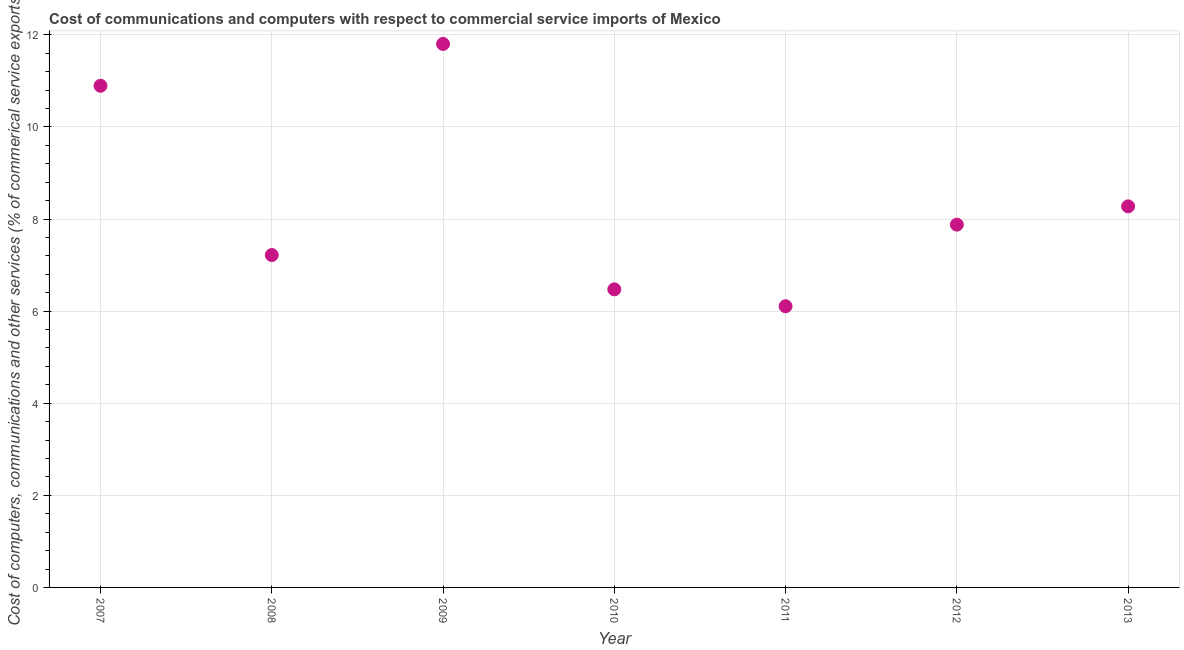What is the  computer and other services in 2010?
Keep it short and to the point. 6.47. Across all years, what is the maximum  computer and other services?
Your response must be concise. 11.8. Across all years, what is the minimum  computer and other services?
Your answer should be compact. 6.11. In which year was the  computer and other services maximum?
Your answer should be compact. 2009. What is the sum of the cost of communications?
Keep it short and to the point. 58.64. What is the difference between the  computer and other services in 2011 and 2012?
Give a very brief answer. -1.77. What is the average cost of communications per year?
Your answer should be very brief. 8.38. What is the median cost of communications?
Make the answer very short. 7.88. What is the ratio of the  computer and other services in 2007 to that in 2008?
Offer a very short reply. 1.51. Is the cost of communications in 2009 less than that in 2012?
Offer a very short reply. No. Is the difference between the cost of communications in 2008 and 2012 greater than the difference between any two years?
Offer a terse response. No. What is the difference between the highest and the second highest cost of communications?
Ensure brevity in your answer.  0.91. What is the difference between the highest and the lowest  computer and other services?
Your response must be concise. 5.7. In how many years, is the cost of communications greater than the average cost of communications taken over all years?
Keep it short and to the point. 2. Does the cost of communications monotonically increase over the years?
Your response must be concise. No. How many years are there in the graph?
Your response must be concise. 7. What is the difference between two consecutive major ticks on the Y-axis?
Make the answer very short. 2. Are the values on the major ticks of Y-axis written in scientific E-notation?
Offer a terse response. No. What is the title of the graph?
Your answer should be very brief. Cost of communications and computers with respect to commercial service imports of Mexico. What is the label or title of the Y-axis?
Provide a short and direct response. Cost of computers, communications and other services (% of commerical service exports). What is the Cost of computers, communications and other services (% of commerical service exports) in 2007?
Provide a succinct answer. 10.89. What is the Cost of computers, communications and other services (% of commerical service exports) in 2008?
Give a very brief answer. 7.22. What is the Cost of computers, communications and other services (% of commerical service exports) in 2009?
Make the answer very short. 11.8. What is the Cost of computers, communications and other services (% of commerical service exports) in 2010?
Make the answer very short. 6.47. What is the Cost of computers, communications and other services (% of commerical service exports) in 2011?
Keep it short and to the point. 6.11. What is the Cost of computers, communications and other services (% of commerical service exports) in 2012?
Your answer should be compact. 7.88. What is the Cost of computers, communications and other services (% of commerical service exports) in 2013?
Make the answer very short. 8.27. What is the difference between the Cost of computers, communications and other services (% of commerical service exports) in 2007 and 2008?
Provide a short and direct response. 3.67. What is the difference between the Cost of computers, communications and other services (% of commerical service exports) in 2007 and 2009?
Your answer should be very brief. -0.91. What is the difference between the Cost of computers, communications and other services (% of commerical service exports) in 2007 and 2010?
Give a very brief answer. 4.42. What is the difference between the Cost of computers, communications and other services (% of commerical service exports) in 2007 and 2011?
Offer a terse response. 4.79. What is the difference between the Cost of computers, communications and other services (% of commerical service exports) in 2007 and 2012?
Provide a succinct answer. 3.01. What is the difference between the Cost of computers, communications and other services (% of commerical service exports) in 2007 and 2013?
Make the answer very short. 2.62. What is the difference between the Cost of computers, communications and other services (% of commerical service exports) in 2008 and 2009?
Provide a succinct answer. -4.58. What is the difference between the Cost of computers, communications and other services (% of commerical service exports) in 2008 and 2010?
Make the answer very short. 0.75. What is the difference between the Cost of computers, communications and other services (% of commerical service exports) in 2008 and 2011?
Offer a very short reply. 1.11. What is the difference between the Cost of computers, communications and other services (% of commerical service exports) in 2008 and 2012?
Offer a very short reply. -0.66. What is the difference between the Cost of computers, communications and other services (% of commerical service exports) in 2008 and 2013?
Your answer should be very brief. -1.06. What is the difference between the Cost of computers, communications and other services (% of commerical service exports) in 2009 and 2010?
Ensure brevity in your answer.  5.33. What is the difference between the Cost of computers, communications and other services (% of commerical service exports) in 2009 and 2011?
Provide a succinct answer. 5.7. What is the difference between the Cost of computers, communications and other services (% of commerical service exports) in 2009 and 2012?
Make the answer very short. 3.92. What is the difference between the Cost of computers, communications and other services (% of commerical service exports) in 2009 and 2013?
Your answer should be very brief. 3.53. What is the difference between the Cost of computers, communications and other services (% of commerical service exports) in 2010 and 2011?
Provide a succinct answer. 0.37. What is the difference between the Cost of computers, communications and other services (% of commerical service exports) in 2010 and 2012?
Make the answer very short. -1.41. What is the difference between the Cost of computers, communications and other services (% of commerical service exports) in 2010 and 2013?
Keep it short and to the point. -1.8. What is the difference between the Cost of computers, communications and other services (% of commerical service exports) in 2011 and 2012?
Offer a very short reply. -1.77. What is the difference between the Cost of computers, communications and other services (% of commerical service exports) in 2011 and 2013?
Provide a succinct answer. -2.17. What is the difference between the Cost of computers, communications and other services (% of commerical service exports) in 2012 and 2013?
Your answer should be very brief. -0.4. What is the ratio of the Cost of computers, communications and other services (% of commerical service exports) in 2007 to that in 2008?
Provide a succinct answer. 1.51. What is the ratio of the Cost of computers, communications and other services (% of commerical service exports) in 2007 to that in 2009?
Keep it short and to the point. 0.92. What is the ratio of the Cost of computers, communications and other services (% of commerical service exports) in 2007 to that in 2010?
Offer a very short reply. 1.68. What is the ratio of the Cost of computers, communications and other services (% of commerical service exports) in 2007 to that in 2011?
Provide a succinct answer. 1.78. What is the ratio of the Cost of computers, communications and other services (% of commerical service exports) in 2007 to that in 2012?
Offer a terse response. 1.38. What is the ratio of the Cost of computers, communications and other services (% of commerical service exports) in 2007 to that in 2013?
Make the answer very short. 1.32. What is the ratio of the Cost of computers, communications and other services (% of commerical service exports) in 2008 to that in 2009?
Ensure brevity in your answer.  0.61. What is the ratio of the Cost of computers, communications and other services (% of commerical service exports) in 2008 to that in 2010?
Keep it short and to the point. 1.11. What is the ratio of the Cost of computers, communications and other services (% of commerical service exports) in 2008 to that in 2011?
Give a very brief answer. 1.18. What is the ratio of the Cost of computers, communications and other services (% of commerical service exports) in 2008 to that in 2012?
Your answer should be compact. 0.92. What is the ratio of the Cost of computers, communications and other services (% of commerical service exports) in 2008 to that in 2013?
Provide a succinct answer. 0.87. What is the ratio of the Cost of computers, communications and other services (% of commerical service exports) in 2009 to that in 2010?
Ensure brevity in your answer.  1.82. What is the ratio of the Cost of computers, communications and other services (% of commerical service exports) in 2009 to that in 2011?
Provide a short and direct response. 1.93. What is the ratio of the Cost of computers, communications and other services (% of commerical service exports) in 2009 to that in 2012?
Keep it short and to the point. 1.5. What is the ratio of the Cost of computers, communications and other services (% of commerical service exports) in 2009 to that in 2013?
Offer a very short reply. 1.43. What is the ratio of the Cost of computers, communications and other services (% of commerical service exports) in 2010 to that in 2011?
Your answer should be compact. 1.06. What is the ratio of the Cost of computers, communications and other services (% of commerical service exports) in 2010 to that in 2012?
Give a very brief answer. 0.82. What is the ratio of the Cost of computers, communications and other services (% of commerical service exports) in 2010 to that in 2013?
Offer a very short reply. 0.78. What is the ratio of the Cost of computers, communications and other services (% of commerical service exports) in 2011 to that in 2012?
Provide a succinct answer. 0.78. What is the ratio of the Cost of computers, communications and other services (% of commerical service exports) in 2011 to that in 2013?
Ensure brevity in your answer.  0.74. 